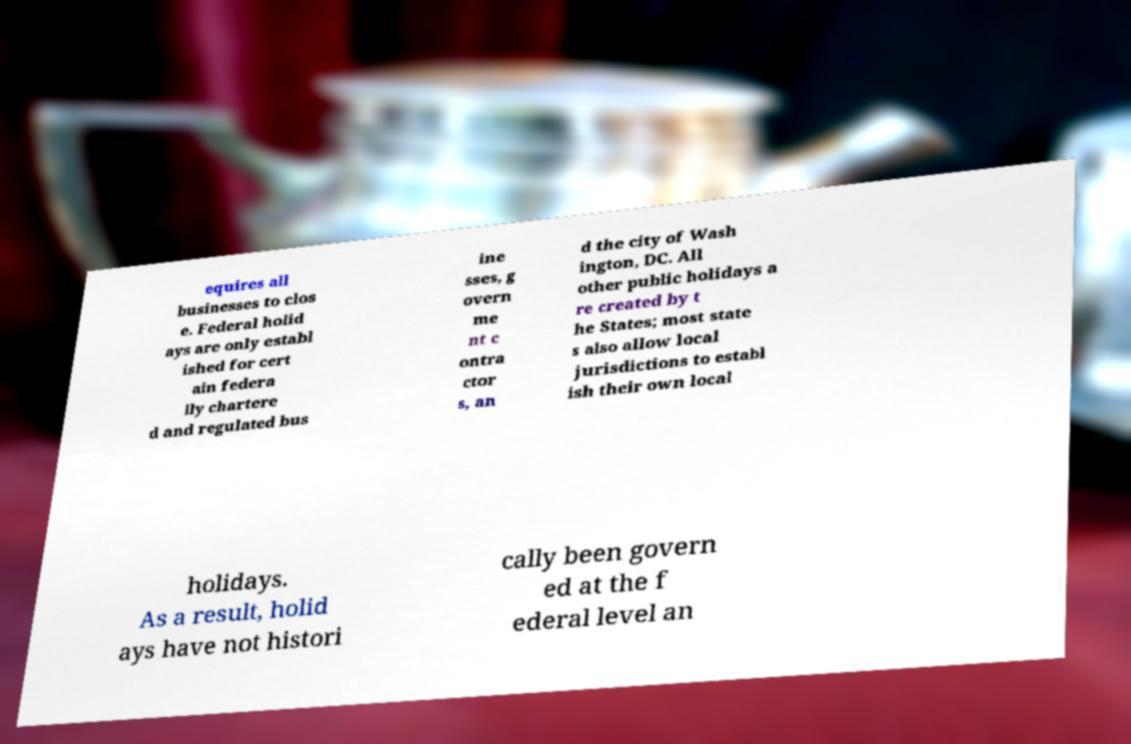For documentation purposes, I need the text within this image transcribed. Could you provide that? equires all businesses to clos e. Federal holid ays are only establ ished for cert ain federa lly chartere d and regulated bus ine sses, g overn me nt c ontra ctor s, an d the city of Wash ington, DC. All other public holidays a re created by t he States; most state s also allow local jurisdictions to establ ish their own local holidays. As a result, holid ays have not histori cally been govern ed at the f ederal level an 